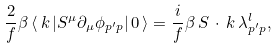<formula> <loc_0><loc_0><loc_500><loc_500>\frac { 2 } { f } \beta \left < \, k \, | S ^ { \mu } \partial _ { \mu } \phi _ { p ^ { \prime } p } | \, 0 \, \right > = \frac { i } { f } \beta \, S \, \cdot \, k \, \lambda ^ { l } _ { p ^ { \prime } p } ,</formula> 